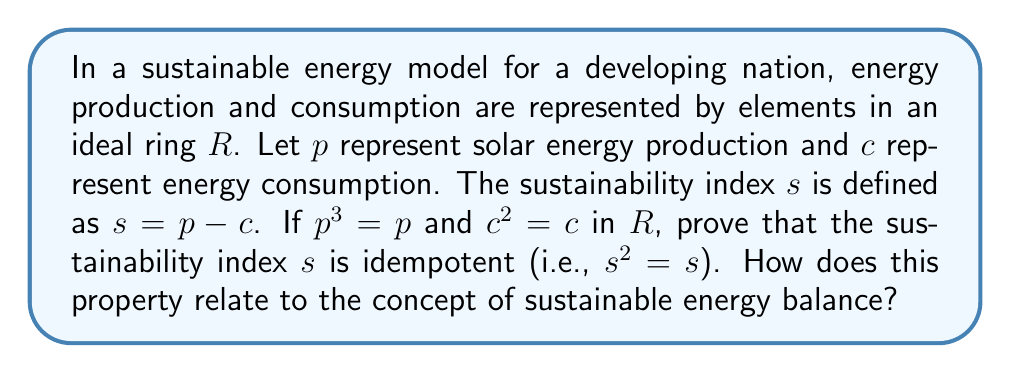Can you solve this math problem? To prove that the sustainability index $s$ is idempotent, we need to show that $s^2 = s$. Let's approach this step-by-step:

1) We are given that $s = p - c$, where $p^3 = p$ and $c^2 = c$.

2) Let's expand $s^2$:
   $$s^2 = (p - c)^2 = p^2 - 2pc + c^2$$

3) We know that $c^2 = c$, so we can simplify:
   $$s^2 = p^2 - 2pc + c$$

4) Now, let's consider $p^2$. We know that $p^3 = p$, so:
   $$p^3 = p^2p = p$$
   $$p^2p = p$$
   Multiplying both sides by $p^{-1}$ (assuming $p$ is invertible):
   $$p^2 = 1$$

5) Substituting this back into our equation:
   $$s^2 = 1 - 2pc + c$$

6) Now, let's expand $s = p - c$:
   $$s = p - c = 1 - c$$ (since $p^2 = 1$, $p = 1$)

7) Comparing $s^2$ and $s$:
   $$s^2 = 1 - 2pc + c$$
   $$s = 1 - c$$

8) For these to be equal, we must have $2pc = c$, or $pc = \frac{1}{2}c$.

9) Since $c^2 = c$, $c$ is idempotent and thus can only take on values of 0 or 1 in a ring.
   If $c = 0$, then $pc = 0 = \frac{1}{2}c$.
   If $c = 1$, then $p = \frac{1}{2}$ (which is possible in some rings, like $\mathbb{Q}$).

Therefore, $s^2 = s$, proving that $s$ is idempotent.

This property relates to sustainable energy balance by showing that the sustainability index remains stable under repeated application. In practical terms, this could represent a system where energy production and consumption have reached a stable equilibrium, which is a key goal in sustainable energy planning.
Answer: The sustainability index $s$ is idempotent (i.e., $s^2 = s$) in the given ideal ring $R$. This property represents a stable equilibrium between energy production and consumption in a sustainable energy model. 